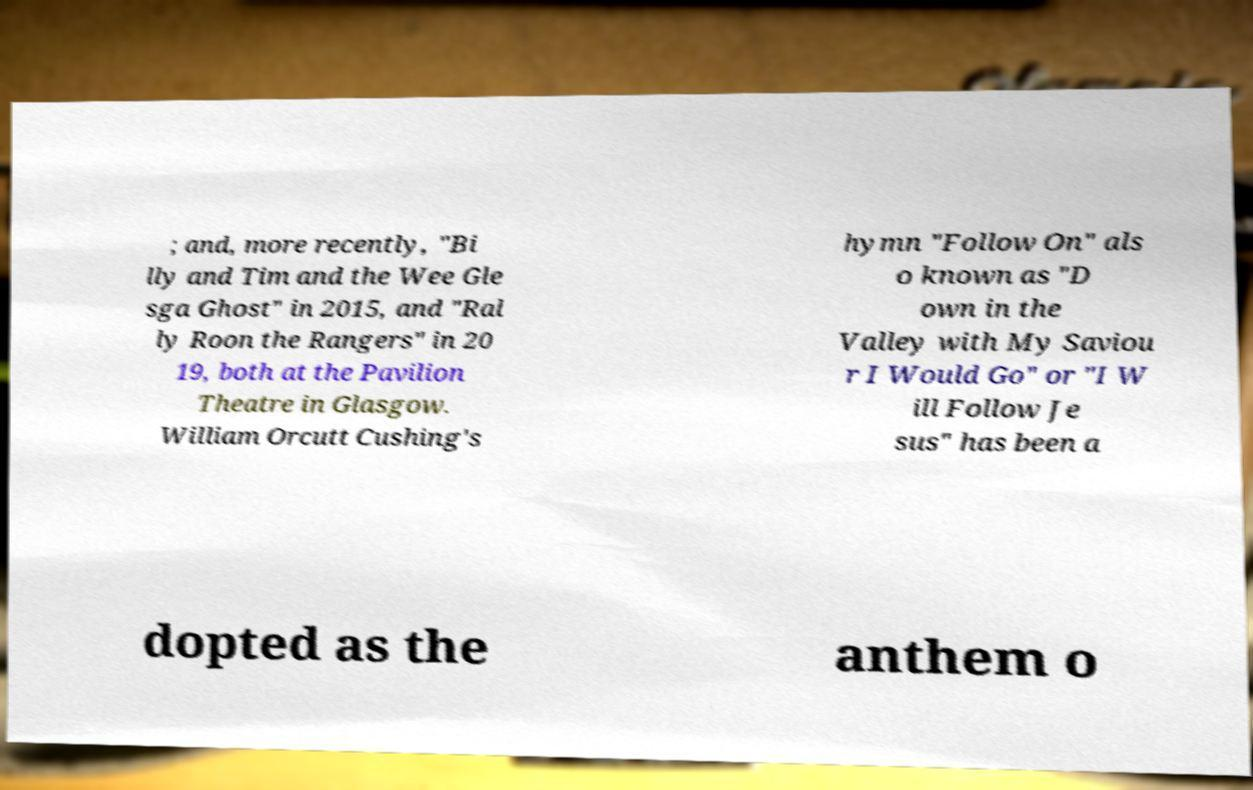What messages or text are displayed in this image? I need them in a readable, typed format. ; and, more recently, "Bi lly and Tim and the Wee Gle sga Ghost" in 2015, and "Ral ly Roon the Rangers" in 20 19, both at the Pavilion Theatre in Glasgow. William Orcutt Cushing's hymn "Follow On" als o known as "D own in the Valley with My Saviou r I Would Go" or "I W ill Follow Je sus" has been a dopted as the anthem o 